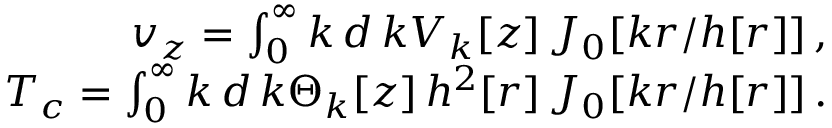<formula> <loc_0><loc_0><loc_500><loc_500>\begin{array} { r } { { v _ { z } = \int _ { 0 } ^ { \infty } k \, d \, { k } V _ { k } [ z ] \, J _ { 0 } [ k r / h [ r ] ] } \, , \ } \\ { T _ { c } = \int _ { 0 } ^ { \infty } k \, d \, { k } \Theta _ { k } [ z ] \, { h ^ { 2 } } [ r ] \, J _ { 0 } [ k r / h [ r ] ] \, . \ } \end{array}</formula> 